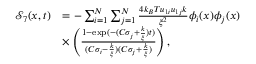<formula> <loc_0><loc_0><loc_500><loc_500>\begin{array} { r l } { \mathcal { S } _ { 7 } ( x , t ) } & { = - \sum _ { i = 1 } ^ { N } \sum _ { j = 1 } ^ { N } \frac { 4 k _ { B } T u _ { 1 i } u _ { 1 j } k } { \xi ^ { 2 } } \phi _ { i } ( x ) \phi _ { j } ( x ) } \\ & { \times \left ( \frac { 1 - \exp ( - ( C \sigma _ { j } + \frac { k } { \xi } ) t ) } { ( C \sigma _ { i } - \frac { k } { \xi } ) ( C \sigma _ { j } + \frac { k } { \xi } ) } \right ) , } \end{array}</formula> 